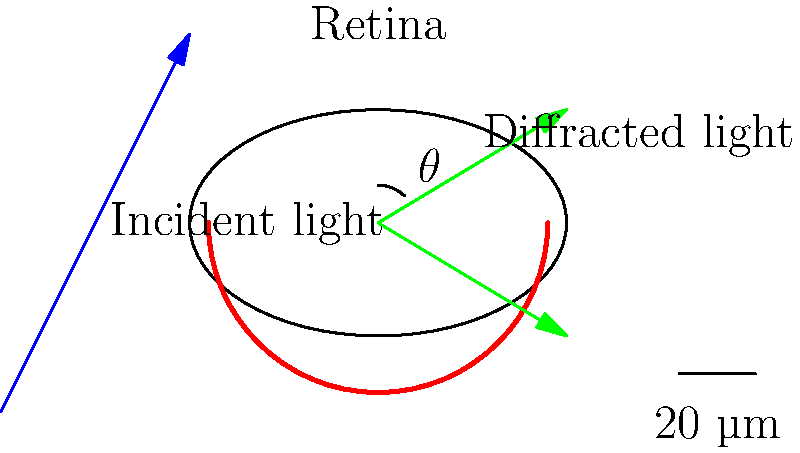In the diagram, light is shown diffracting through a diabetic retina. If the wavelength of the incident light is 500 nm and the angle $\theta$ between the central maximum and the first-order diffraction maximum is 15°, what is the approximate size of the retinal features causing the diffraction? To solve this problem, we'll use the diffraction grating equation:

1. The diffraction grating equation is:
   $$ d \sin \theta = m \lambda $$
   where:
   $d$ = size of diffracting features
   $\theta$ = angle between central maximum and first-order maximum
   $m$ = order of diffraction (1 for first-order)
   $\lambda$ = wavelength of light

2. We are given:
   $\theta = 15°$
   $\lambda = 500 \text{ nm}$
   $m = 1$ (first-order maximum)

3. Rearrange the equation to solve for $d$:
   $$ d = \frac{m \lambda}{\sin \theta} $$

4. Convert 15° to radians:
   $15° \times \frac{\pi}{180°} = 0.2618 \text{ radians}$

5. Substitute the values and calculate:
   $$ d = \frac{1 \times 500 \text{ nm}}{\sin(0.2618)} $$
   $$ d = \frac{500 \text{ nm}}{0.2588} $$
   $$ d \approx 1932 \text{ nm} \approx 1.93 \mu\text{m} $$

6. Round to two significant figures:
   $d \approx 1.9 \mu\text{m}$

This size is consistent with typical retinal features such as photoreceptor cells or small blood vessels that might be affected in diabetic retinopathy.
Answer: $1.9 \mu\text{m}$ 